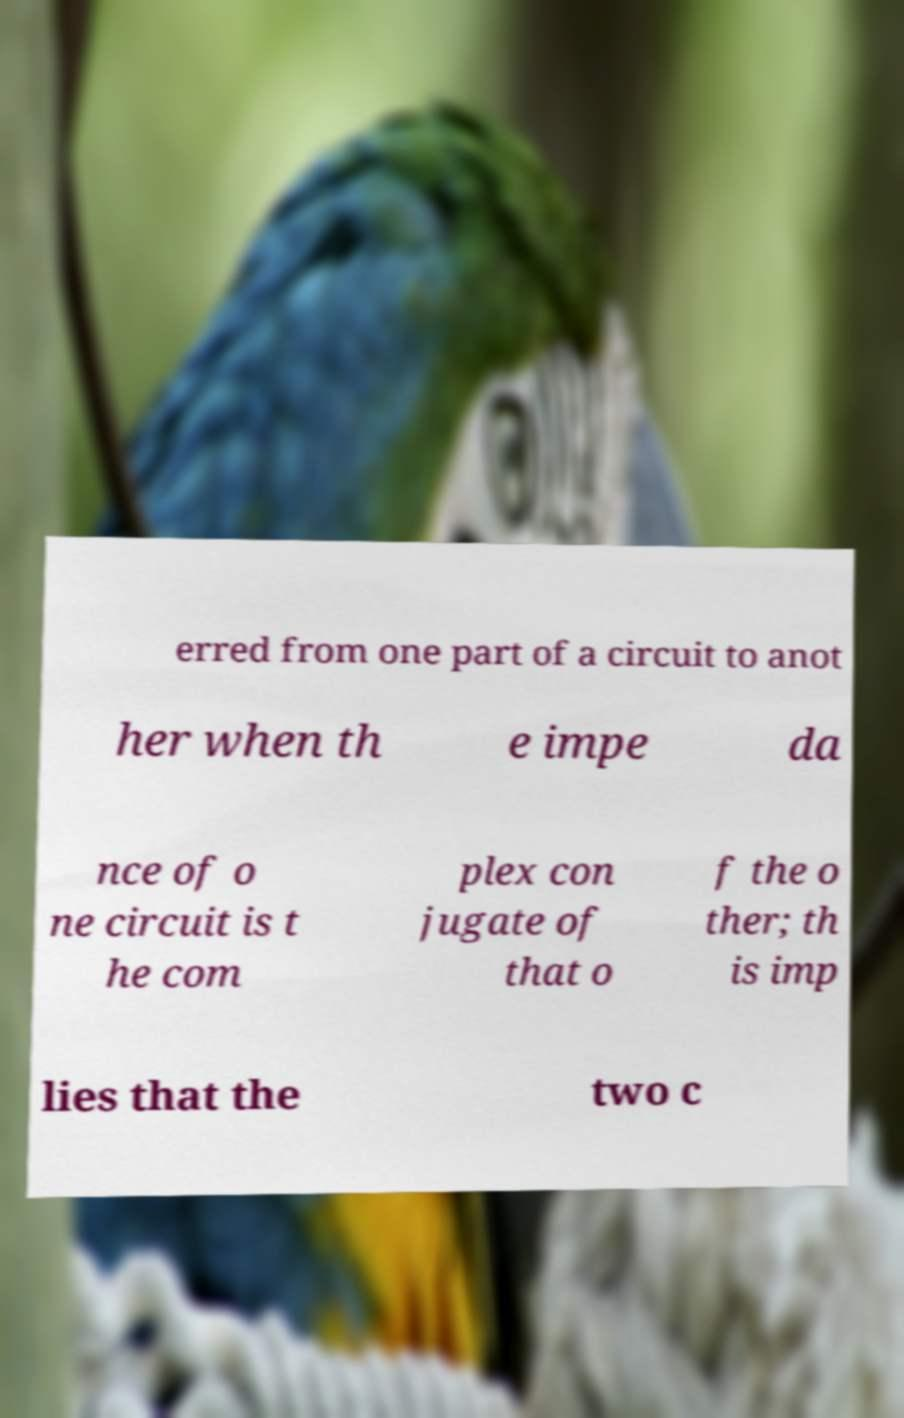Please identify and transcribe the text found in this image. erred from one part of a circuit to anot her when th e impe da nce of o ne circuit is t he com plex con jugate of that o f the o ther; th is imp lies that the two c 